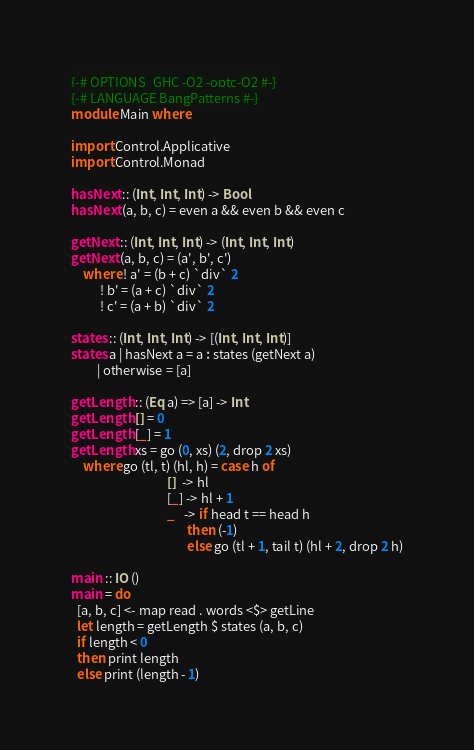<code> <loc_0><loc_0><loc_500><loc_500><_Haskell_>{-# OPTIONS_GHC -O2 -optc-O2 #-}
{-# LANGUAGE BangPatterns #-}
module Main where

import Control.Applicative
import Control.Monad

hasNext :: (Int, Int, Int) -> Bool
hasNext (a, b, c) = even a && even b && even c

getNext :: (Int, Int, Int) -> (Int, Int, Int)
getNext (a, b, c) = (a', b', c')
    where ! a' = (b + c) `div` 2
          ! b' = (a + c) `div` 2
          ! c' = (a + b) `div` 2

states :: (Int, Int, Int) -> [(Int, Int, Int)]
states a | hasNext a = a : states (getNext a)
         | otherwise = [a]

getLength :: (Eq a) => [a] -> Int
getLength [] = 0
getLength [_] = 1
getLength xs = go (0, xs) (2, drop 2 xs)
    where go (tl, t) (hl, h) = case h of
                                 []  -> hl
                                 [_] -> hl + 1
                                 _   -> if head t == head h
                                        then (-1)
                                        else go (tl + 1, tail t) (hl + 2, drop 2 h)

main :: IO ()
main = do
  [a, b, c] <- map read . words <$> getLine
  let length = getLength $ states (a, b, c)
  if length < 0
  then print length
  else print (length - 1)
</code> 